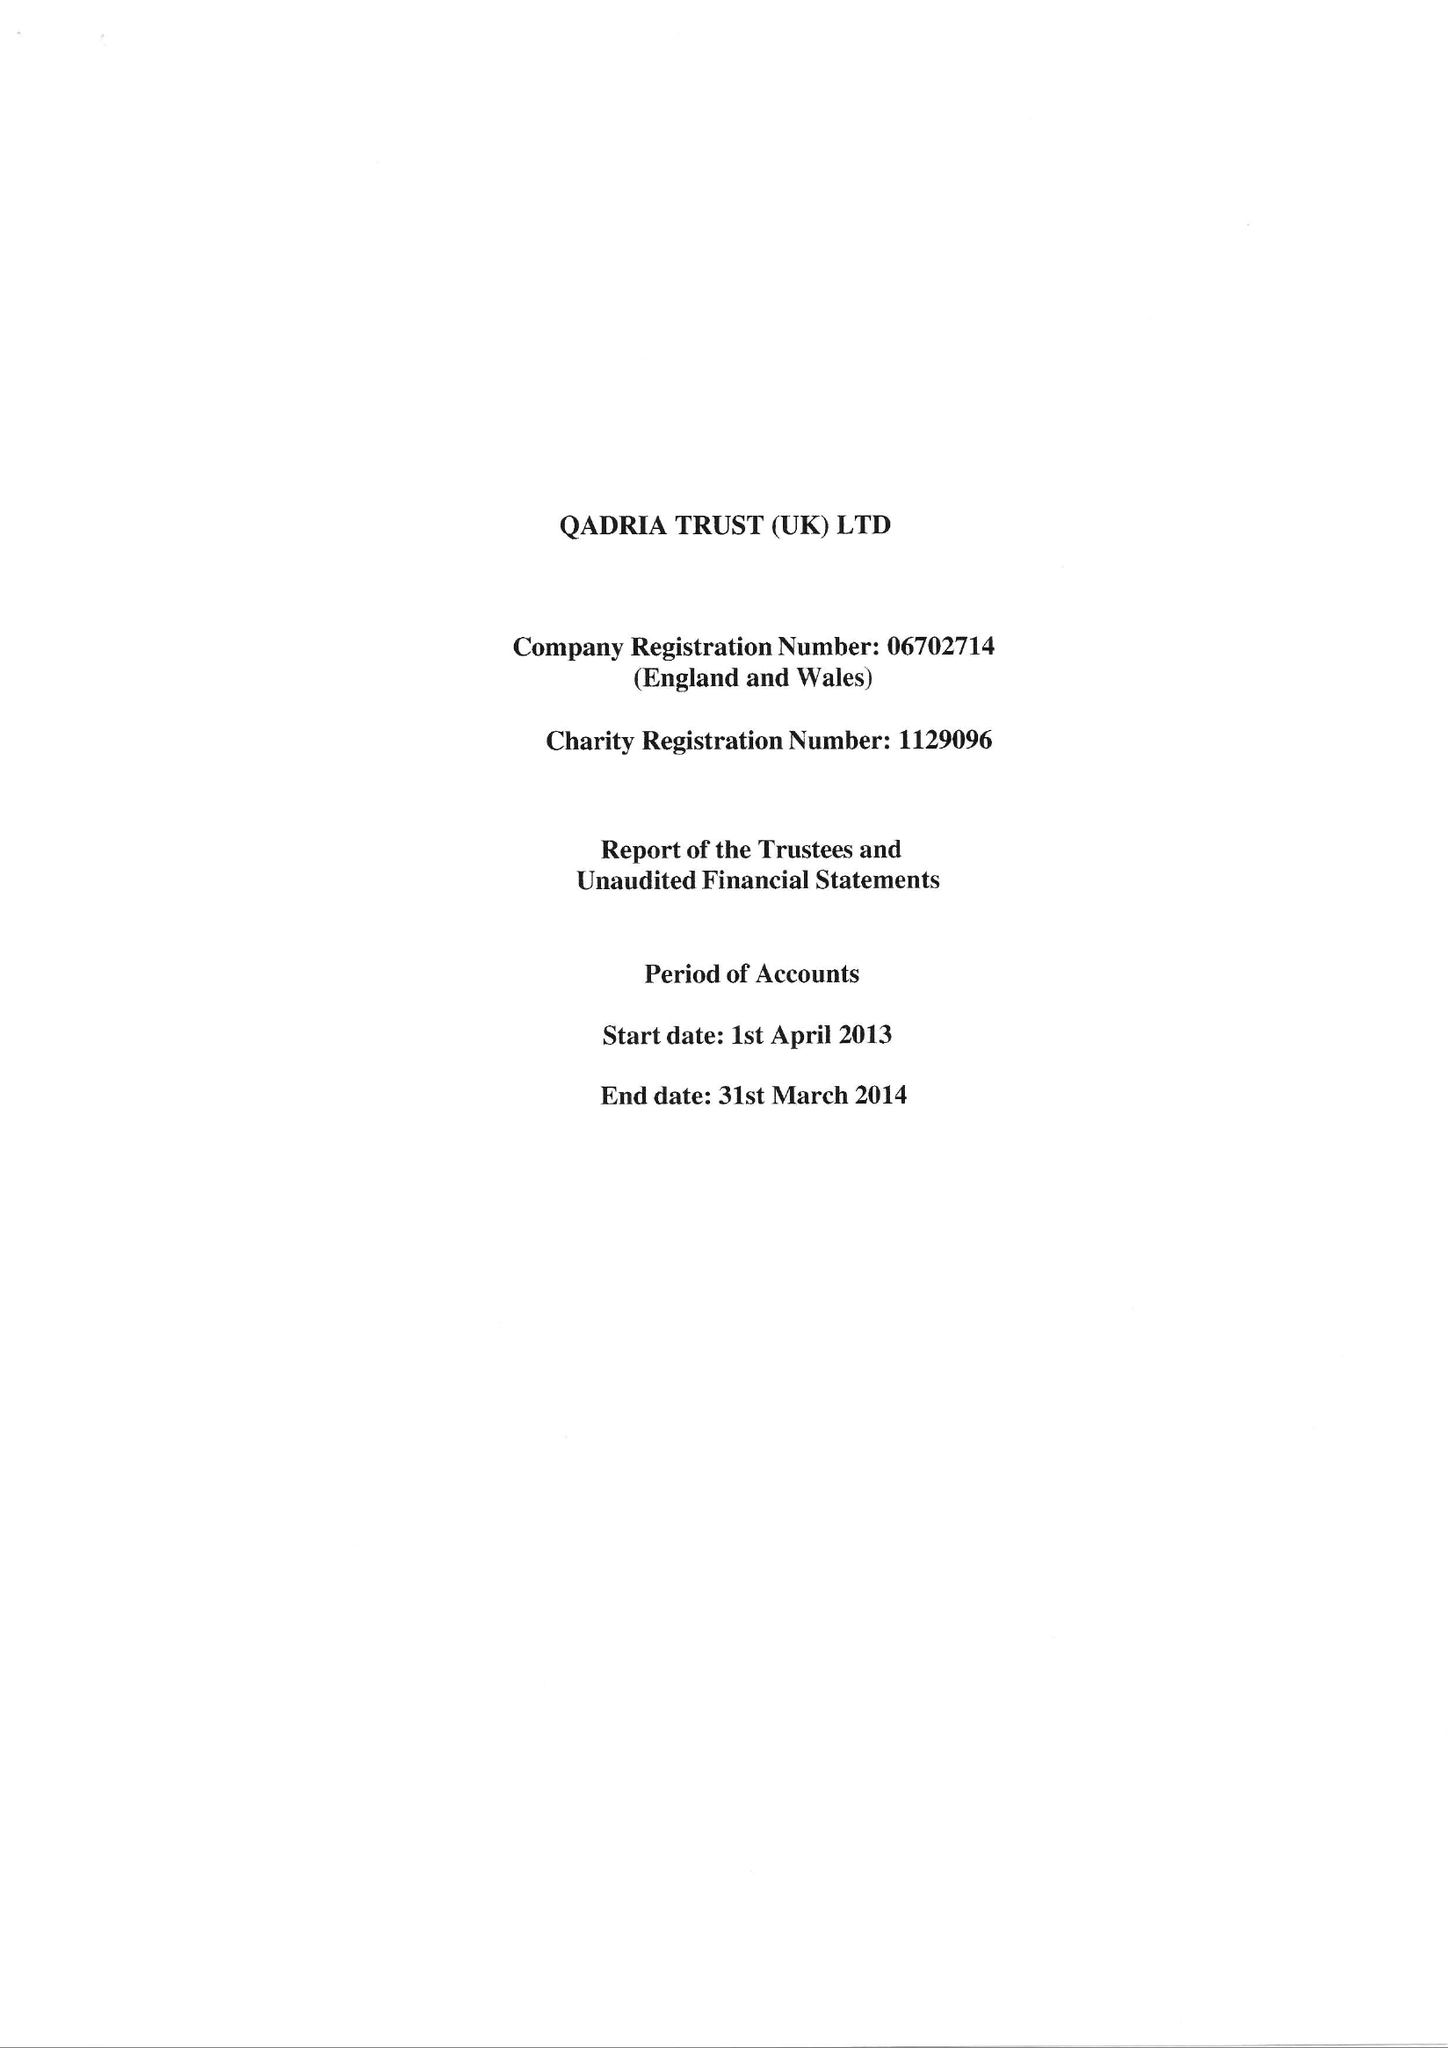What is the value for the report_date?
Answer the question using a single word or phrase. 2014-03-31 